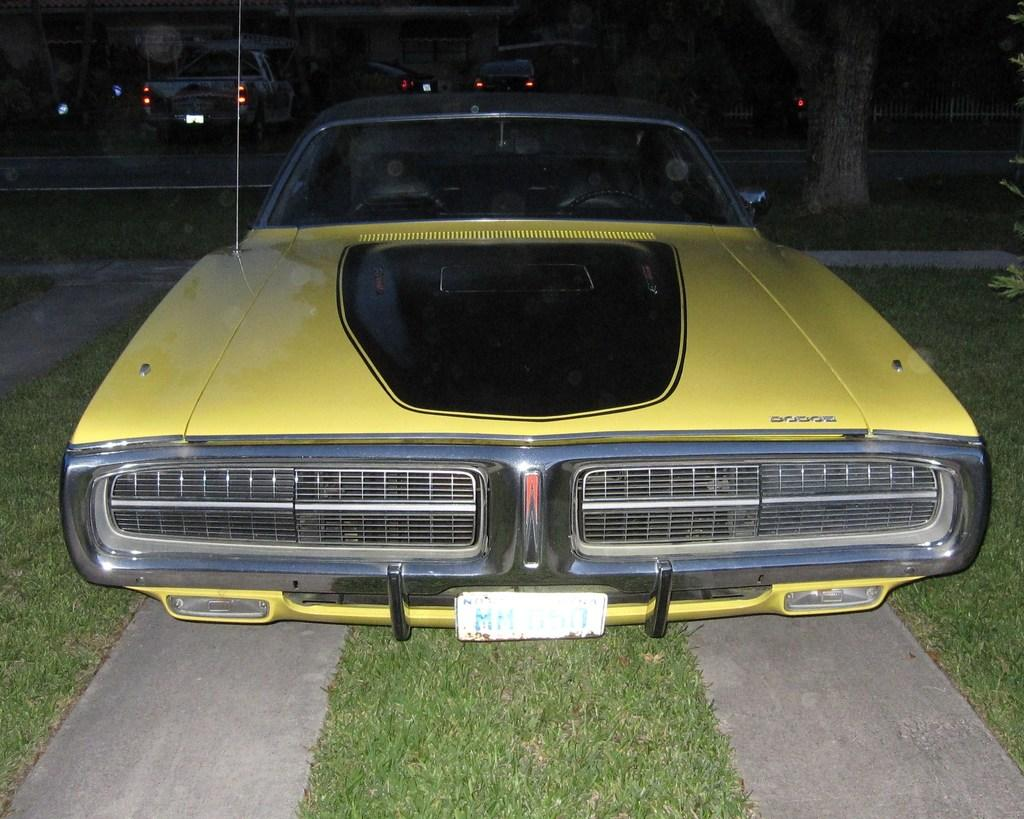What type of vehicles can be seen in the image? There are cars in the image. What is located at the bottom of the image? Grass is present at the bottom of the image. What type of vegetation is visible in the image? There are trees and plants visible in the image. Where is the fencing located in the image? The fencing is in the top right corner of the image. What type of apparatus is being used by the trees in the image? There is no apparatus being used by the trees in the image; they are simply standing. What kind of instrument is being played by the plants in the image? There is no instrument being played by the plants in the image; they are stationary. 